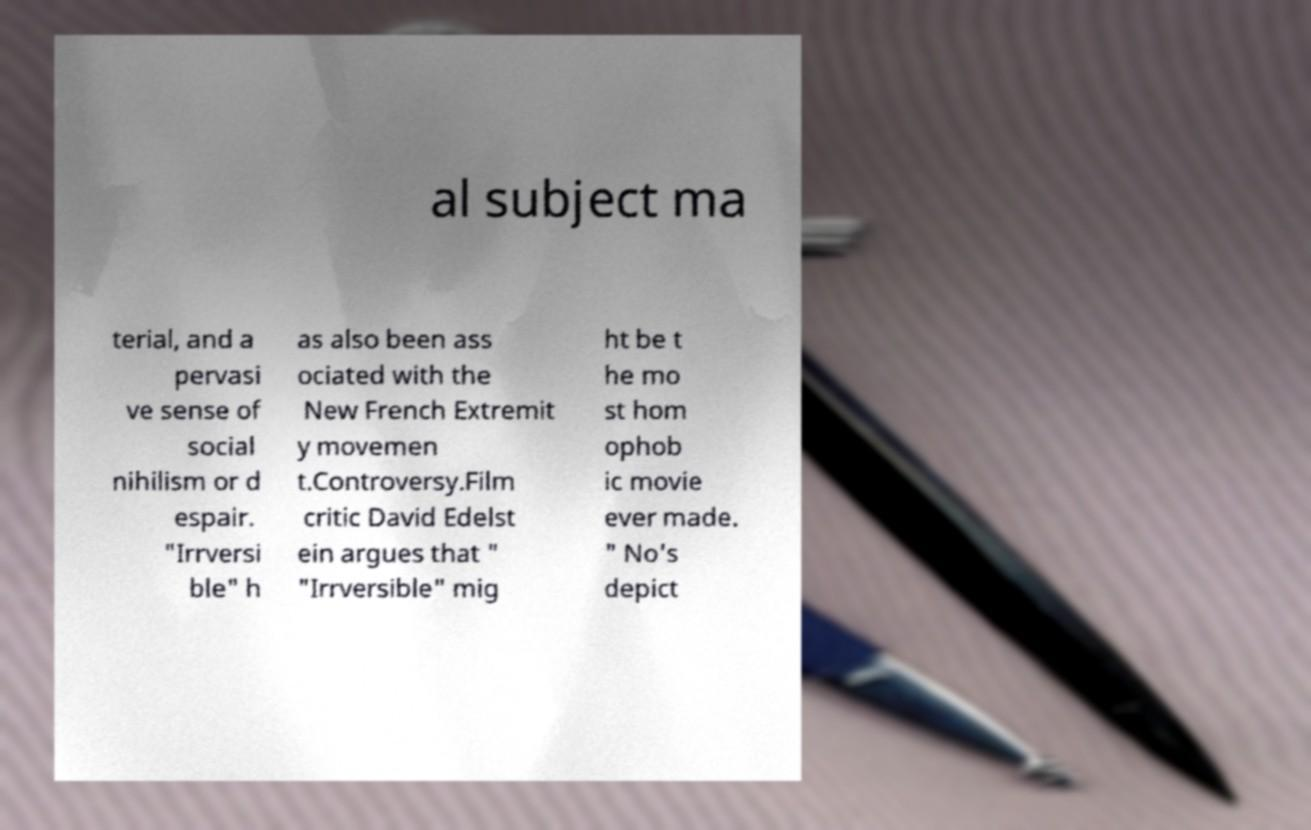Could you assist in decoding the text presented in this image and type it out clearly? al subject ma terial, and a pervasi ve sense of social nihilism or d espair. "Irrversi ble" h as also been ass ociated with the New French Extremit y movemen t.Controversy.Film critic David Edelst ein argues that " "Irrversible" mig ht be t he mo st hom ophob ic movie ever made. " No's depict 